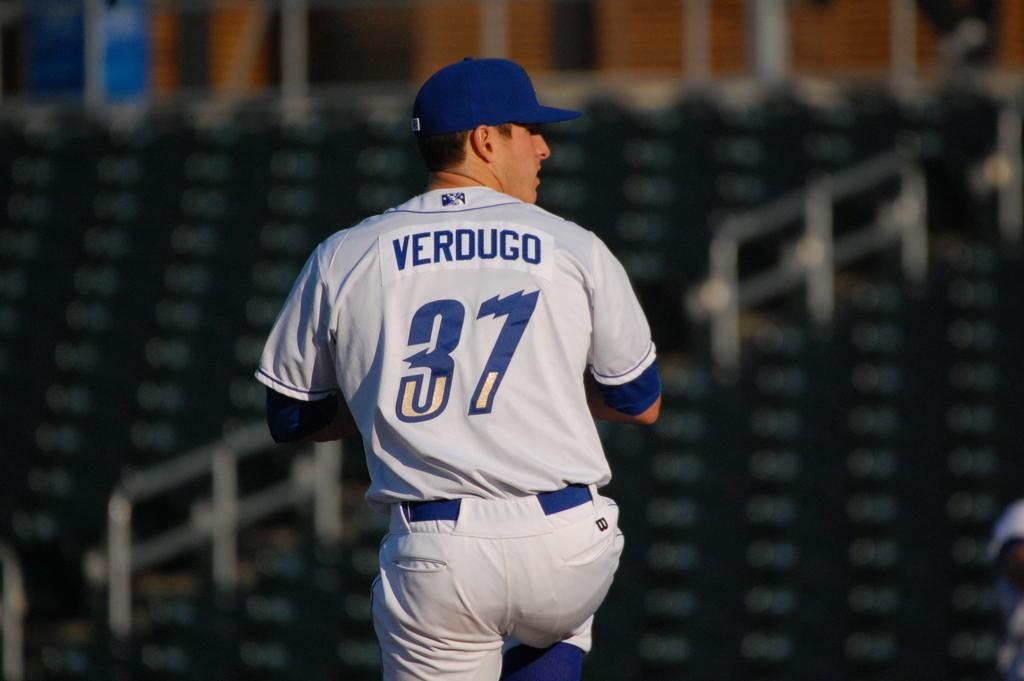Provide a one-sentence caption for the provided image. At any empty stadium, a picture with the name Verdugo and the number 37 on his jersey is getting ready to pitch. 